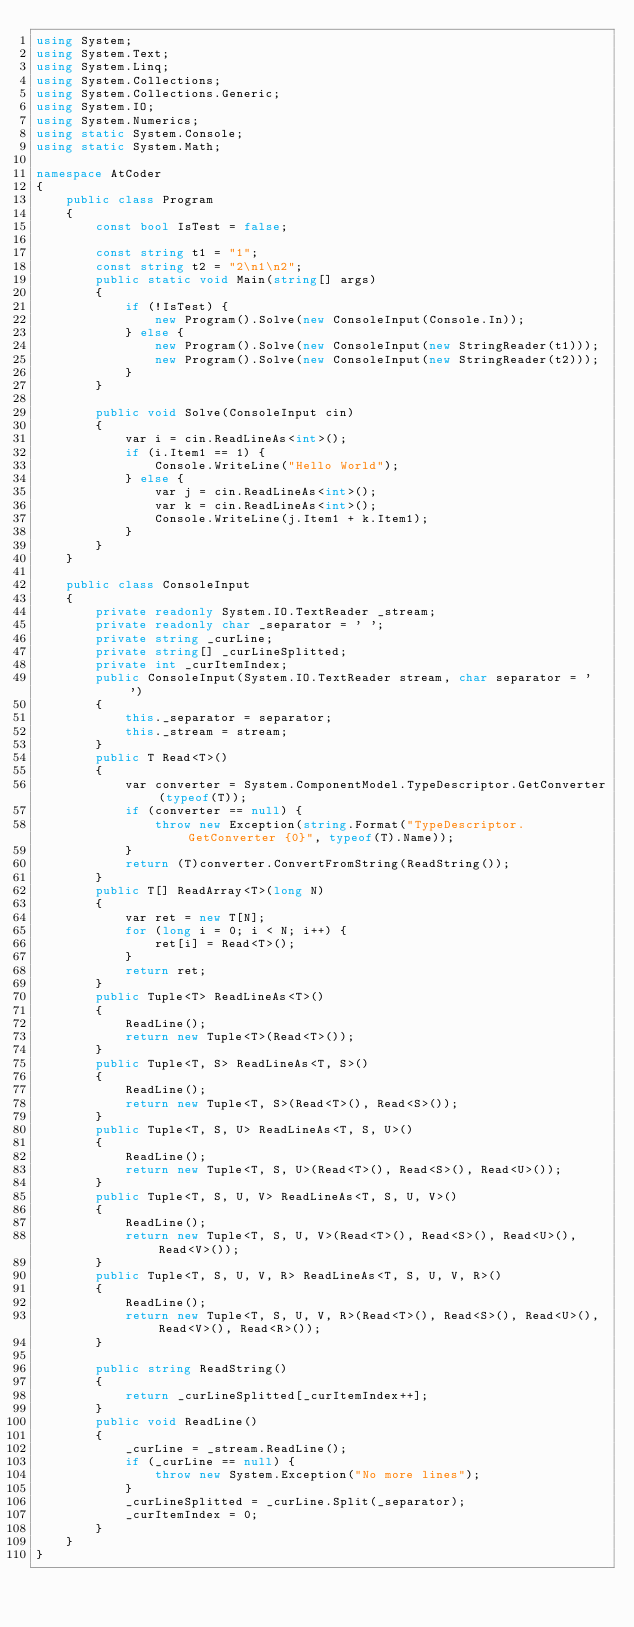Convert code to text. <code><loc_0><loc_0><loc_500><loc_500><_C#_>using System;
using System.Text;
using System.Linq;
using System.Collections;
using System.Collections.Generic;
using System.IO;
using System.Numerics;
using static System.Console;
using static System.Math;

namespace AtCoder
{
    public class Program
    {
        const bool IsTest = false;

        const string t1 = "1";
        const string t2 = "2\n1\n2";
        public static void Main(string[] args)
        {
            if (!IsTest) {
                new Program().Solve(new ConsoleInput(Console.In));
            } else {
                new Program().Solve(new ConsoleInput(new StringReader(t1)));
                new Program().Solve(new ConsoleInput(new StringReader(t2)));
            }
        }

        public void Solve(ConsoleInput cin)
        {
            var i = cin.ReadLineAs<int>();
            if (i.Item1 == 1) {
                Console.WriteLine("Hello World");
            } else {
                var j = cin.ReadLineAs<int>();
                var k = cin.ReadLineAs<int>();
                Console.WriteLine(j.Item1 + k.Item1);
            }
        }
    }

    public class ConsoleInput
    {
        private readonly System.IO.TextReader _stream;
        private readonly char _separator = ' ';
        private string _curLine;
        private string[] _curLineSplitted;
        private int _curItemIndex;
        public ConsoleInput(System.IO.TextReader stream, char separator = ' ')
        {
            this._separator = separator;
            this._stream = stream;
        }
        public T Read<T>()
        {
            var converter = System.ComponentModel.TypeDescriptor.GetConverter(typeof(T));
            if (converter == null) {
                throw new Exception(string.Format("TypeDescriptor.GetConverter {0}", typeof(T).Name));
            }
            return (T)converter.ConvertFromString(ReadString());
        }
        public T[] ReadArray<T>(long N)
        {
            var ret = new T[N];
            for (long i = 0; i < N; i++) {
                ret[i] = Read<T>();
            }
            return ret;
        }
        public Tuple<T> ReadLineAs<T>()
        {
            ReadLine();
            return new Tuple<T>(Read<T>());
        }
        public Tuple<T, S> ReadLineAs<T, S>()
        {
            ReadLine();
            return new Tuple<T, S>(Read<T>(), Read<S>());
        }
        public Tuple<T, S, U> ReadLineAs<T, S, U>()
        {
            ReadLine();
            return new Tuple<T, S, U>(Read<T>(), Read<S>(), Read<U>());
        }
        public Tuple<T, S, U, V> ReadLineAs<T, S, U, V>()
        {
            ReadLine();
            return new Tuple<T, S, U, V>(Read<T>(), Read<S>(), Read<U>(), Read<V>());
        }
        public Tuple<T, S, U, V, R> ReadLineAs<T, S, U, V, R>()
        {
            ReadLine();
            return new Tuple<T, S, U, V, R>(Read<T>(), Read<S>(), Read<U>(), Read<V>(), Read<R>());
        }

        public string ReadString()
        {
            return _curLineSplitted[_curItemIndex++];
        }
        public void ReadLine()
        {
            _curLine = _stream.ReadLine();
            if (_curLine == null) {
                throw new System.Exception("No more lines");
            }
            _curLineSplitted = _curLine.Split(_separator);
            _curItemIndex = 0;
        }
    }
}

</code> 